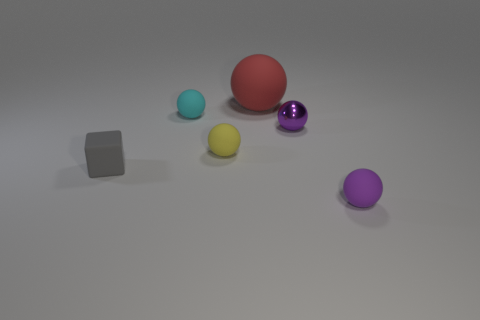How many other objects are the same color as the metallic thing?
Provide a short and direct response. 1. How many gray objects are either cubes or small spheres?
Your response must be concise. 1. What color is the small object that is both on the right side of the large red sphere and in front of the small yellow thing?
Keep it short and to the point. Purple. Is the material of the small purple object right of the small purple shiny sphere the same as the tiny ball behind the small purple metal ball?
Ensure brevity in your answer.  Yes. Is the number of gray objects that are in front of the purple matte ball greater than the number of cyan matte objects to the left of the gray matte object?
Your answer should be very brief. No. The yellow rubber thing that is the same size as the purple rubber thing is what shape?
Your answer should be very brief. Sphere. What number of things are either tiny balls or small spheres behind the gray rubber block?
Provide a succinct answer. 4. Do the small metallic object and the block have the same color?
Your response must be concise. No. There is a small shiny thing; how many rubber cubes are on the left side of it?
Provide a short and direct response. 1. There is a large sphere that is the same material as the small gray cube; what is its color?
Offer a very short reply. Red. 